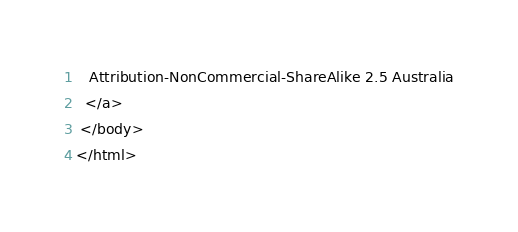Convert code to text. <code><loc_0><loc_0><loc_500><loc_500><_HTML_>   Attribution-NonCommercial-ShareAlike 2.5 Australia
  </a>
 </body>
</html>
</code> 